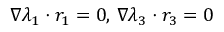Convert formula to latex. <formula><loc_0><loc_0><loc_500><loc_500>\nabla \lambda _ { 1 } \cdot r _ { 1 } = 0 , \, \nabla \lambda _ { 3 } \cdot r _ { 3 } = 0</formula> 